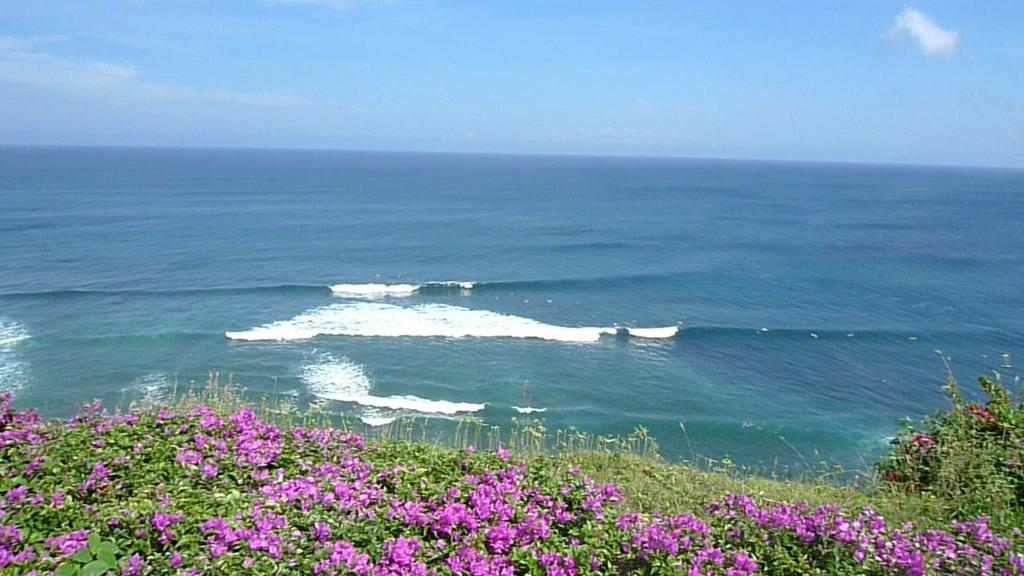What types of vegetation are at the bottom of the image? There are plants and flowers at the bottom of the image. What is located in the middle of the image? There is water in the middle of the image. What part of the natural environment is visible at the top of the image? The sky is visible at the top of the image. How much salt is dissolved in the water in the image? There is no information about salt in the image, so it cannot be determined how much salt is dissolved in the water. 